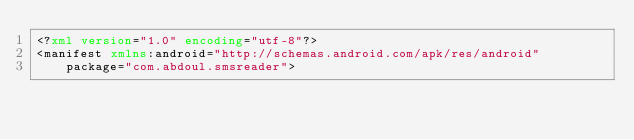Convert code to text. <code><loc_0><loc_0><loc_500><loc_500><_XML_><?xml version="1.0" encoding="utf-8"?>
<manifest xmlns:android="http://schemas.android.com/apk/res/android"
    package="com.abdoul.smsreader">
</code> 